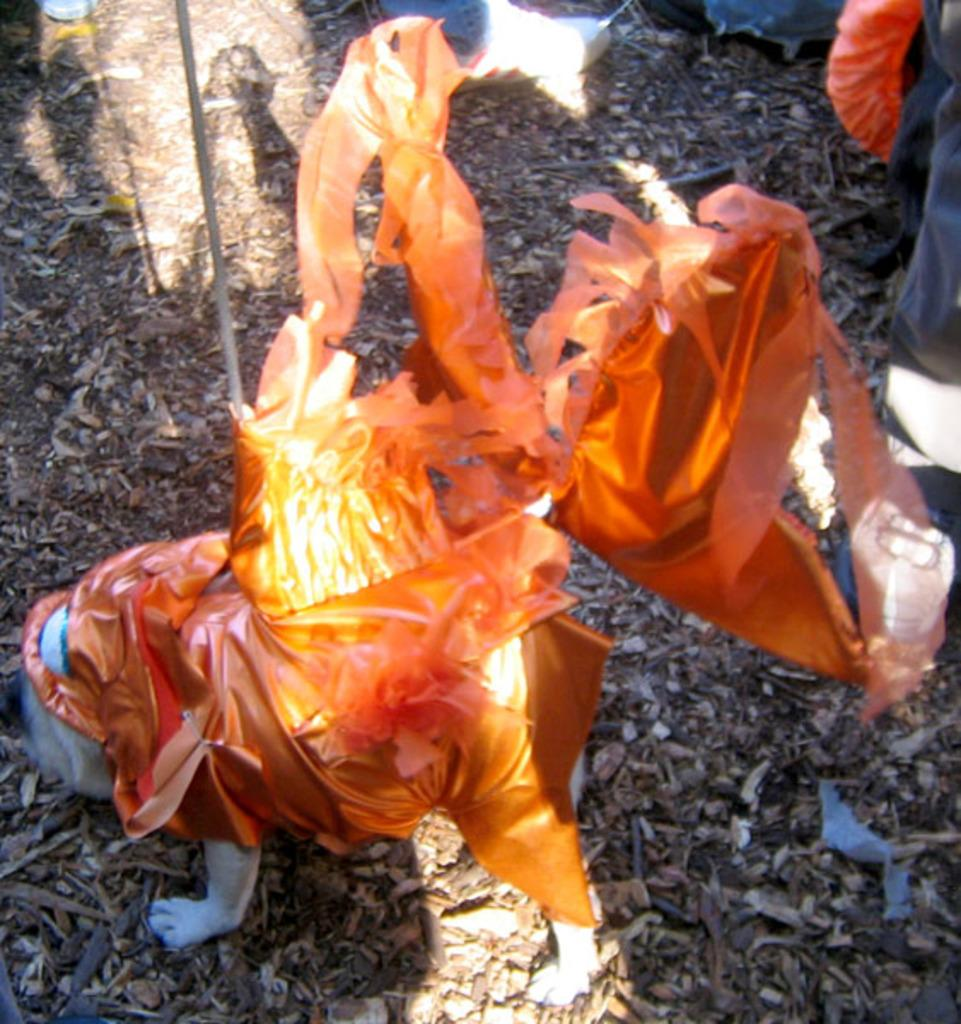What type of animal is in the image? There is a dog in the image. How is the dog dressed? The dog is wearing an orange dress. What object is near the dog? There is a stick near the dog. Can you describe any human presence in the image? Some legs of persons are visible in the image. What can be seen on the ground in the image? There are dried leaves on the ground in the image. What type of crate is the tiger sitting on in the image? There is no tiger or crate present in the image; it features a dog wearing an orange dress. 